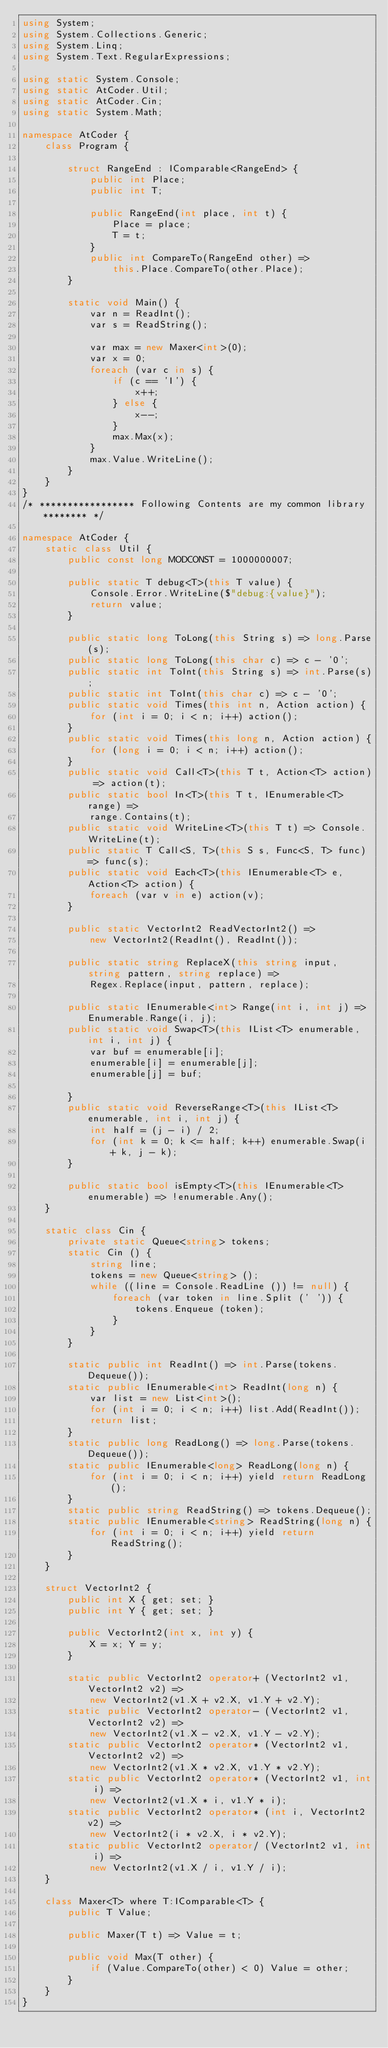Convert code to text. <code><loc_0><loc_0><loc_500><loc_500><_C#_>using System;
using System.Collections.Generic;
using System.Linq;
using System.Text.RegularExpressions;

using static System.Console;
using static AtCoder.Util;
using static AtCoder.Cin;
using static System.Math;

namespace AtCoder {
    class Program {

        struct RangeEnd : IComparable<RangeEnd> {
            public int Place;
            public int T;

            public RangeEnd(int place, int t) {
                Place = place;
                T = t;
            }
            public int CompareTo(RangeEnd other) => 
                this.Place.CompareTo(other.Place);
        }

        static void Main() {
            var n = ReadInt();
            var s = ReadString();

            var max = new Maxer<int>(0);
            var x = 0;
            foreach (var c in s) {
                if (c == 'I') {
                    x++;
                } else {
                    x--;
                }
                max.Max(x);
            }
            max.Value.WriteLine();
        }
    }
}
/* ***************** Following Contents are my common library ******** */

namespace AtCoder {
    static class Util {
        public const long MODCONST = 1000000007;

        public static T debug<T>(this T value) {
            Console.Error.WriteLine($"debug:{value}");
            return value;
        }

        public static long ToLong(this String s) => long.Parse(s);
        public static long ToLong(this char c) => c - '0';
        public static int ToInt(this String s) => int.Parse(s);
        public static int ToInt(this char c) => c - '0';
        public static void Times(this int n, Action action) {
            for (int i = 0; i < n; i++) action();
        }
        public static void Times(this long n, Action action) {
            for (long i = 0; i < n; i++) action();
        }
        public static void Call<T>(this T t, Action<T> action) => action(t);
        public static bool In<T>(this T t, IEnumerable<T> range) =>
            range.Contains(t);
        public static void WriteLine<T>(this T t) => Console.WriteLine(t);
        public static T Call<S, T>(this S s, Func<S, T> func) => func(s);
        public static void Each<T>(this IEnumerable<T> e, Action<T> action) {
            foreach (var v in e) action(v);
        }

        public static VectorInt2 ReadVectorInt2() => 
            new VectorInt2(ReadInt(), ReadInt());

        public static string ReplaceX(this string input, string pattern, string replace) =>
            Regex.Replace(input, pattern, replace);

        public static IEnumerable<int> Range(int i, int j) => Enumerable.Range(i, j);
        public static void Swap<T>(this IList<T> enumerable, int i, int j) {
            var buf = enumerable[i];
            enumerable[i] = enumerable[j];
            enumerable[j] = buf;

        }
        public static void ReverseRange<T>(this IList<T> enumerable, int i, int j) {
            int half = (j - i) / 2;
            for (int k = 0; k <= half; k++) enumerable.Swap(i + k, j - k);
        }
        
        public static bool isEmpty<T>(this IEnumerable<T> enumerable) => !enumerable.Any();
    }

    static class Cin {
        private static Queue<string> tokens;
        static Cin () {
            string line;
            tokens = new Queue<string> ();
            while ((line = Console.ReadLine ()) != null) {
                foreach (var token in line.Split (' ')) {
                    tokens.Enqueue (token);
                }
            }
        }

        static public int ReadInt() => int.Parse(tokens.Dequeue());
        static public IEnumerable<int> ReadInt(long n) {
            var list = new List<int>();
            for (int i = 0; i < n; i++) list.Add(ReadInt());
            return list;
        }
        static public long ReadLong() => long.Parse(tokens.Dequeue());
        static public IEnumerable<long> ReadLong(long n) {
            for (int i = 0; i < n; i++) yield return ReadLong();
        }
        static public string ReadString() => tokens.Dequeue();
        static public IEnumerable<string> ReadString(long n) {
            for (int i = 0; i < n; i++) yield return ReadString();
        }
    }

    struct VectorInt2 {
        public int X { get; set; }
        public int Y { get; set; }

        public VectorInt2(int x, int y) {
            X = x; Y = y;
        }

        static public VectorInt2 operator+ (VectorInt2 v1, VectorInt2 v2) =>
            new VectorInt2(v1.X + v2.X, v1.Y + v2.Y);
        static public VectorInt2 operator- (VectorInt2 v1, VectorInt2 v2) =>
            new VectorInt2(v1.X - v2.X, v1.Y - v2.Y);
        static public VectorInt2 operator* (VectorInt2 v1, VectorInt2 v2) =>
            new VectorInt2(v1.X * v2.X, v1.Y * v2.Y);
        static public VectorInt2 operator* (VectorInt2 v1, int i) =>
            new VectorInt2(v1.X * i, v1.Y * i);
        static public VectorInt2 operator* (int i, VectorInt2 v2) =>
            new VectorInt2(i * v2.X, i * v2.Y);
        static public VectorInt2 operator/ (VectorInt2 v1, int i) =>
            new VectorInt2(v1.X / i, v1.Y / i);
    }

    class Maxer<T> where T:IComparable<T> {
        public T Value;

        public Maxer(T t) => Value = t;

        public void Max(T other) {
            if (Value.CompareTo(other) < 0) Value = other;
        }
    }
}
</code> 